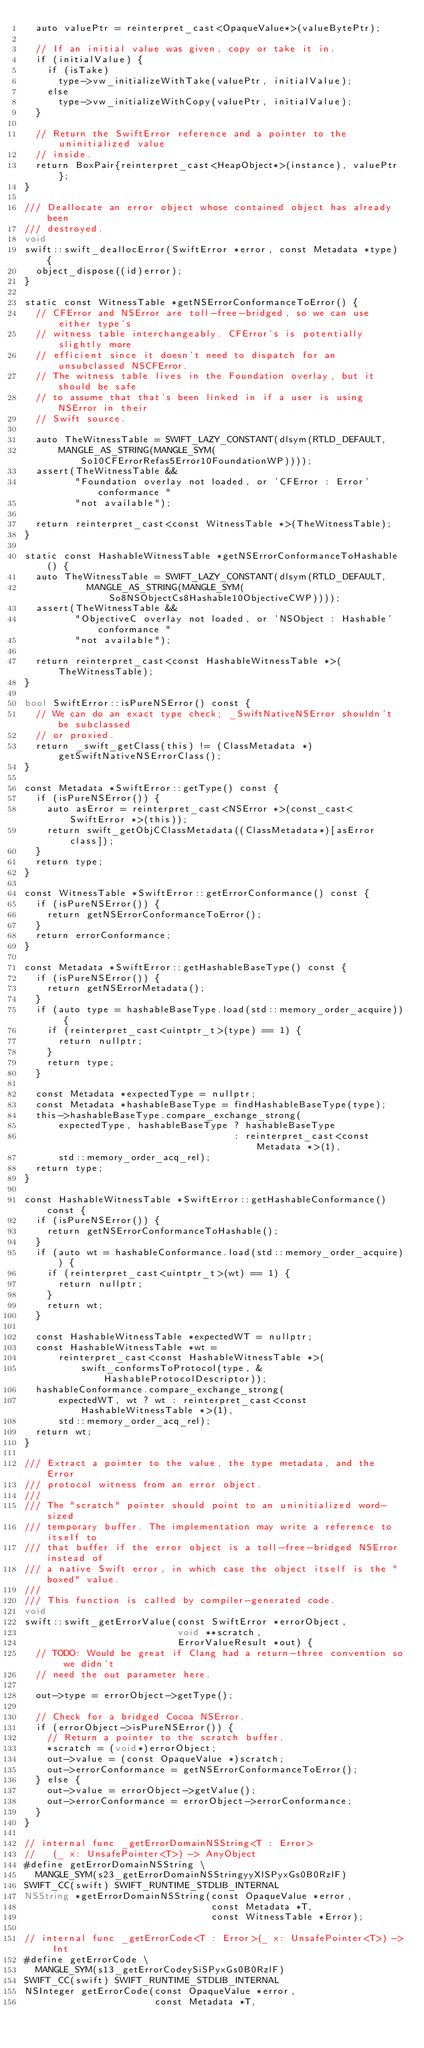Convert code to text. <code><loc_0><loc_0><loc_500><loc_500><_ObjectiveC_>  auto valuePtr = reinterpret_cast<OpaqueValue*>(valueBytePtr);

  // If an initial value was given, copy or take it in.
  if (initialValue) {
    if (isTake)
      type->vw_initializeWithTake(valuePtr, initialValue);
    else
      type->vw_initializeWithCopy(valuePtr, initialValue);
  }

  // Return the SwiftError reference and a pointer to the uninitialized value
  // inside.
  return BoxPair{reinterpret_cast<HeapObject*>(instance), valuePtr};
}

/// Deallocate an error object whose contained object has already been
/// destroyed.
void
swift::swift_deallocError(SwiftError *error, const Metadata *type) {
  object_dispose((id)error);
}

static const WitnessTable *getNSErrorConformanceToError() {
  // CFError and NSError are toll-free-bridged, so we can use either type's
  // witness table interchangeably. CFError's is potentially slightly more
  // efficient since it doesn't need to dispatch for an unsubclassed NSCFError.
  // The witness table lives in the Foundation overlay, but it should be safe
  // to assume that that's been linked in if a user is using NSError in their
  // Swift source.

  auto TheWitnessTable = SWIFT_LAZY_CONSTANT(dlsym(RTLD_DEFAULT,
      MANGLE_AS_STRING(MANGLE_SYM(So10CFErrorRefas5Error10FoundationWP))));
  assert(TheWitnessTable &&
         "Foundation overlay not loaded, or 'CFError : Error' conformance "
         "not available");

  return reinterpret_cast<const WitnessTable *>(TheWitnessTable);
}

static const HashableWitnessTable *getNSErrorConformanceToHashable() {
  auto TheWitnessTable = SWIFT_LAZY_CONSTANT(dlsym(RTLD_DEFAULT,
           MANGLE_AS_STRING(MANGLE_SYM(So8NSObjectCs8Hashable10ObjectiveCWP))));
  assert(TheWitnessTable &&
         "ObjectiveC overlay not loaded, or 'NSObject : Hashable' conformance "
         "not available");

  return reinterpret_cast<const HashableWitnessTable *>(TheWitnessTable);
}

bool SwiftError::isPureNSError() const {
  // We can do an exact type check; _SwiftNativeNSError shouldn't be subclassed
  // or proxied.
  return _swift_getClass(this) != (ClassMetadata *)getSwiftNativeNSErrorClass();
}

const Metadata *SwiftError::getType() const {
  if (isPureNSError()) {
    auto asError = reinterpret_cast<NSError *>(const_cast<SwiftError *>(this));
    return swift_getObjCClassMetadata((ClassMetadata*)[asError class]);
  }
  return type;
}

const WitnessTable *SwiftError::getErrorConformance() const {
  if (isPureNSError()) {
    return getNSErrorConformanceToError();
  }
  return errorConformance;
}

const Metadata *SwiftError::getHashableBaseType() const {
  if (isPureNSError()) {
    return getNSErrorMetadata();
  }
  if (auto type = hashableBaseType.load(std::memory_order_acquire)) {
    if (reinterpret_cast<uintptr_t>(type) == 1) {
      return nullptr;
    }
    return type;
  }

  const Metadata *expectedType = nullptr;
  const Metadata *hashableBaseType = findHashableBaseType(type);
  this->hashableBaseType.compare_exchange_strong(
      expectedType, hashableBaseType ? hashableBaseType
                                     : reinterpret_cast<const Metadata *>(1),
      std::memory_order_acq_rel);
  return type;
}

const HashableWitnessTable *SwiftError::getHashableConformance() const {
  if (isPureNSError()) {
    return getNSErrorConformanceToHashable();
  }
  if (auto wt = hashableConformance.load(std::memory_order_acquire)) {
    if (reinterpret_cast<uintptr_t>(wt) == 1) {
      return nullptr;
    }
    return wt;
  }

  const HashableWitnessTable *expectedWT = nullptr;
  const HashableWitnessTable *wt =
      reinterpret_cast<const HashableWitnessTable *>(
          swift_conformsToProtocol(type, &HashableProtocolDescriptor));
  hashableConformance.compare_exchange_strong(
      expectedWT, wt ? wt : reinterpret_cast<const HashableWitnessTable *>(1),
      std::memory_order_acq_rel);
  return wt;
}

/// Extract a pointer to the value, the type metadata, and the Error
/// protocol witness from an error object.
///
/// The "scratch" pointer should point to an uninitialized word-sized
/// temporary buffer. The implementation may write a reference to itself to
/// that buffer if the error object is a toll-free-bridged NSError instead of
/// a native Swift error, in which case the object itself is the "boxed" value.
///
/// This function is called by compiler-generated code.
void
swift::swift_getErrorValue(const SwiftError *errorObject,
                           void **scratch,
                           ErrorValueResult *out) {
  // TODO: Would be great if Clang had a return-three convention so we didn't
  // need the out parameter here.

  out->type = errorObject->getType();

  // Check for a bridged Cocoa NSError.
  if (errorObject->isPureNSError()) {
    // Return a pointer to the scratch buffer.
    *scratch = (void*)errorObject;
    out->value = (const OpaqueValue *)scratch;
    out->errorConformance = getNSErrorConformanceToError();
  } else {
    out->value = errorObject->getValue();
    out->errorConformance = errorObject->errorConformance;
  }
}

// internal func _getErrorDomainNSString<T : Error>
//   (_ x: UnsafePointer<T>) -> AnyObject
#define getErrorDomainNSString \
  MANGLE_SYM(s23_getErrorDomainNSStringyyXlSPyxGs0B0RzlF)
SWIFT_CC(swift) SWIFT_RUNTIME_STDLIB_INTERNAL
NSString *getErrorDomainNSString(const OpaqueValue *error,
                                 const Metadata *T,
                                 const WitnessTable *Error);

// internal func _getErrorCode<T : Error>(_ x: UnsafePointer<T>) -> Int
#define getErrorCode \
  MANGLE_SYM(s13_getErrorCodeySiSPyxGs0B0RzlF)
SWIFT_CC(swift) SWIFT_RUNTIME_STDLIB_INTERNAL
NSInteger getErrorCode(const OpaqueValue *error,
                       const Metadata *T,</code> 